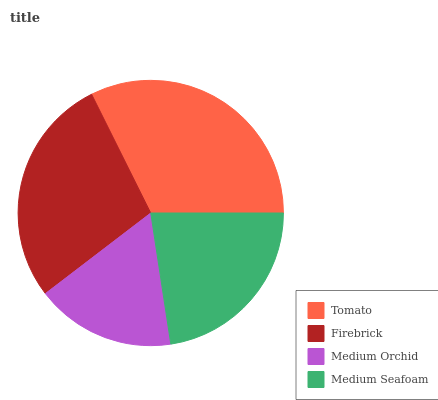Is Medium Orchid the minimum?
Answer yes or no. Yes. Is Tomato the maximum?
Answer yes or no. Yes. Is Firebrick the minimum?
Answer yes or no. No. Is Firebrick the maximum?
Answer yes or no. No. Is Tomato greater than Firebrick?
Answer yes or no. Yes. Is Firebrick less than Tomato?
Answer yes or no. Yes. Is Firebrick greater than Tomato?
Answer yes or no. No. Is Tomato less than Firebrick?
Answer yes or no. No. Is Firebrick the high median?
Answer yes or no. Yes. Is Medium Seafoam the low median?
Answer yes or no. Yes. Is Medium Orchid the high median?
Answer yes or no. No. Is Medium Orchid the low median?
Answer yes or no. No. 